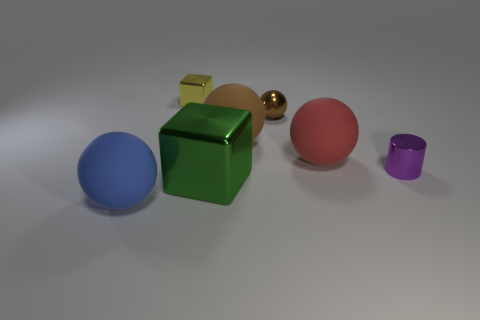Does the matte object behind the red matte thing have the same color as the metal sphere?
Your answer should be very brief. Yes. Are there any brown metallic balls of the same size as the purple thing?
Ensure brevity in your answer.  Yes. The other metallic object that is the same shape as the yellow thing is what color?
Your response must be concise. Green. There is a matte ball that is right of the shiny sphere; is there a big sphere that is behind it?
Make the answer very short. Yes. Does the matte object that is in front of the tiny cylinder have the same shape as the big green metal object?
Your response must be concise. No. There is a blue matte thing; what shape is it?
Make the answer very short. Sphere. What number of small yellow objects have the same material as the green cube?
Ensure brevity in your answer.  1. Do the tiny metallic ball and the big rubber ball that is behind the red object have the same color?
Your answer should be very brief. Yes. What number of big green blocks are there?
Make the answer very short. 1. Is there a object that has the same color as the tiny shiny ball?
Your answer should be very brief. Yes. 